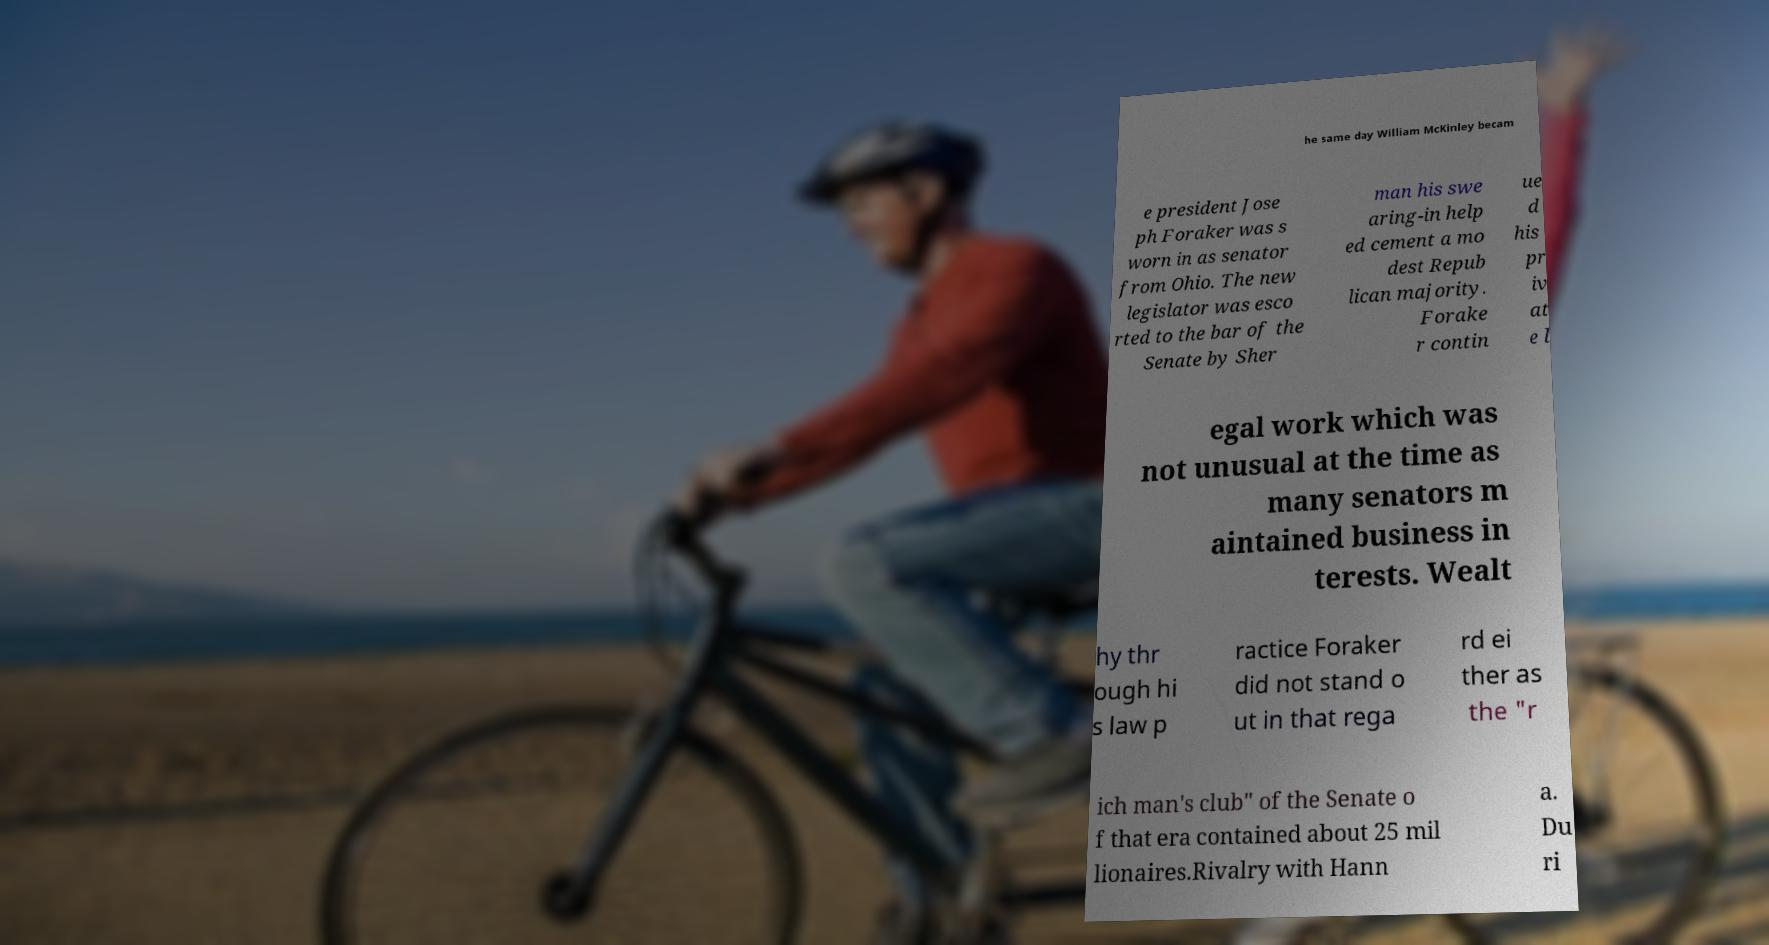What messages or text are displayed in this image? I need them in a readable, typed format. he same day William McKinley becam e president Jose ph Foraker was s worn in as senator from Ohio. The new legislator was esco rted to the bar of the Senate by Sher man his swe aring-in help ed cement a mo dest Repub lican majority. Forake r contin ue d his pr iv at e l egal work which was not unusual at the time as many senators m aintained business in terests. Wealt hy thr ough hi s law p ractice Foraker did not stand o ut in that rega rd ei ther as the "r ich man's club" of the Senate o f that era contained about 25 mil lionaires.Rivalry with Hann a. Du ri 